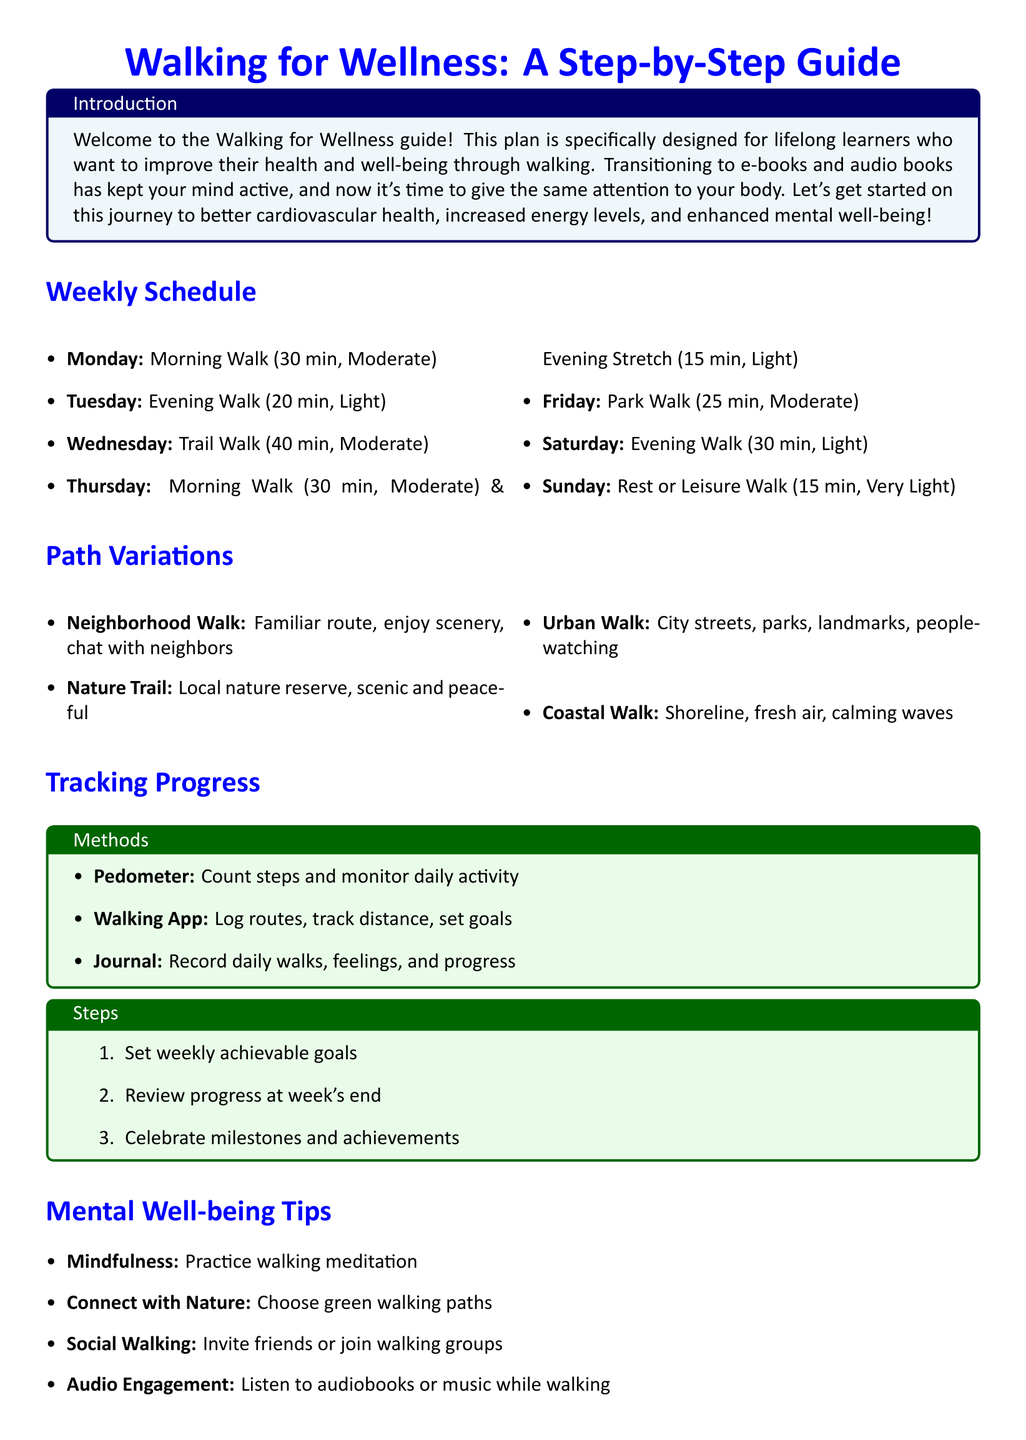What is the title of the guide? The title is prominently displayed at the top of the document.
Answer: Walking for Wellness: A Step-by-Step Guide How long is the Monday walk scheduled for? The document specifies the duration of each walk, including Monday's.
Answer: 30 min What type of walk is suggested for Saturday? Saturdays have a specific walk recommended in the weekly schedule.
Answer: Evening Walk How many minutes is the evening stretch on Thursday? The Thursday schedule includes a specific time for the evening stretch.
Answer: 15 min What is one method mentioned for tracking progress? The document lists various methods in the tracking progress section.
Answer: Pedometer What intensity level is the Wednesday trail walk? The intensity for different walks is outlined in the weekly schedule.
Answer: Moderate What is the purpose of the Walking for Wellness guide? The introduction provides a brief overview of the guide's goals.
Answer: Improve health and well-being Which walking path is suggested for fresh air? The document categorizes different walking paths and their attributes.
Answer: Coastal Walk What is one mental well-being tip provided? The document includes tips specifically aimed at improving mental well-being.
Answer: Mindfulness 